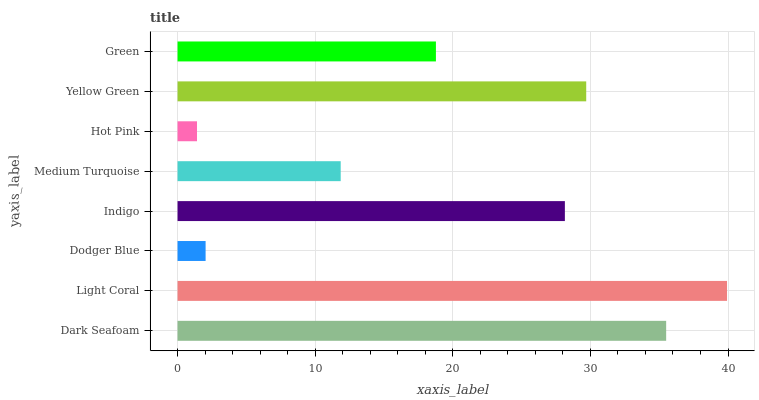Is Hot Pink the minimum?
Answer yes or no. Yes. Is Light Coral the maximum?
Answer yes or no. Yes. Is Dodger Blue the minimum?
Answer yes or no. No. Is Dodger Blue the maximum?
Answer yes or no. No. Is Light Coral greater than Dodger Blue?
Answer yes or no. Yes. Is Dodger Blue less than Light Coral?
Answer yes or no. Yes. Is Dodger Blue greater than Light Coral?
Answer yes or no. No. Is Light Coral less than Dodger Blue?
Answer yes or no. No. Is Indigo the high median?
Answer yes or no. Yes. Is Green the low median?
Answer yes or no. Yes. Is Green the high median?
Answer yes or no. No. Is Dodger Blue the low median?
Answer yes or no. No. 